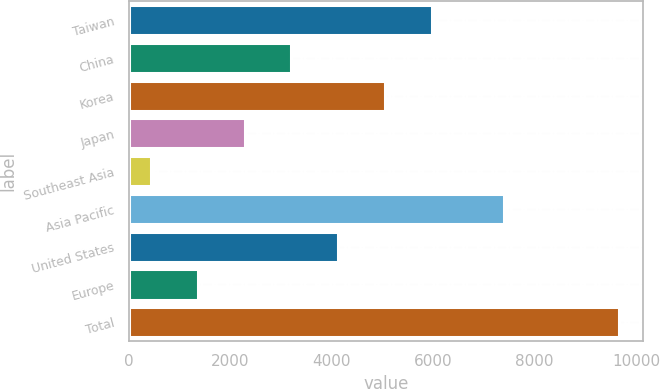<chart> <loc_0><loc_0><loc_500><loc_500><bar_chart><fcel>Taiwan<fcel>China<fcel>Korea<fcel>Japan<fcel>Southeast Asia<fcel>Asia Pacific<fcel>United States<fcel>Europe<fcel>Total<nl><fcel>5968.2<fcel>3200.1<fcel>5045.5<fcel>2277.4<fcel>432<fcel>7387<fcel>4122.8<fcel>1354.7<fcel>9659<nl></chart> 